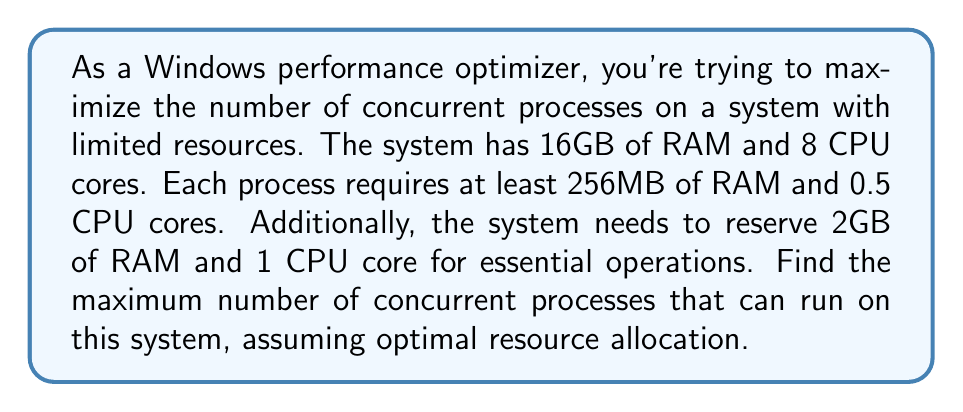What is the answer to this math problem? Let's approach this step-by-step:

1) First, let's calculate the available resources:
   RAM: $16\text{GB} - 2\text{GB} = 14\text{GB} = 14,336\text{MB}$
   CPU cores: $8 - 1 = 7$ cores

2) Now, let's define our variables:
   Let $x$ be the number of concurrent processes.

3) We can set up two inequalities based on the resource constraints:

   For RAM: $256x \leq 14,336$
   For CPU cores: $0.5x \leq 7$

4) Simplify the inequalities:
   RAM: $x \leq 56$
   CPU: $x \leq 14$

5) Since we need to satisfy both conditions, we take the minimum of these two upper bounds:

   $x \leq \min(56, 14) = 14$

6) Since $x$ represents the number of processes, it must be a whole number. Therefore, the maximum value of $x$ is 14.

This means the system can run a maximum of 14 concurrent processes while respecting the given constraints.
Answer: 14 processes 